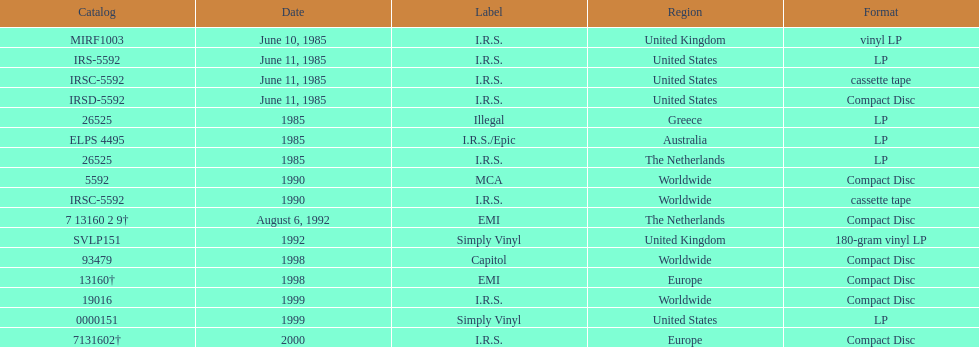Which region has more than one format? United States. 